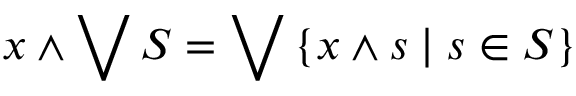<formula> <loc_0><loc_0><loc_500><loc_500>x \wedge \bigvee S = \bigvee \left \{ x \wedge s | s \in S \right \}</formula> 